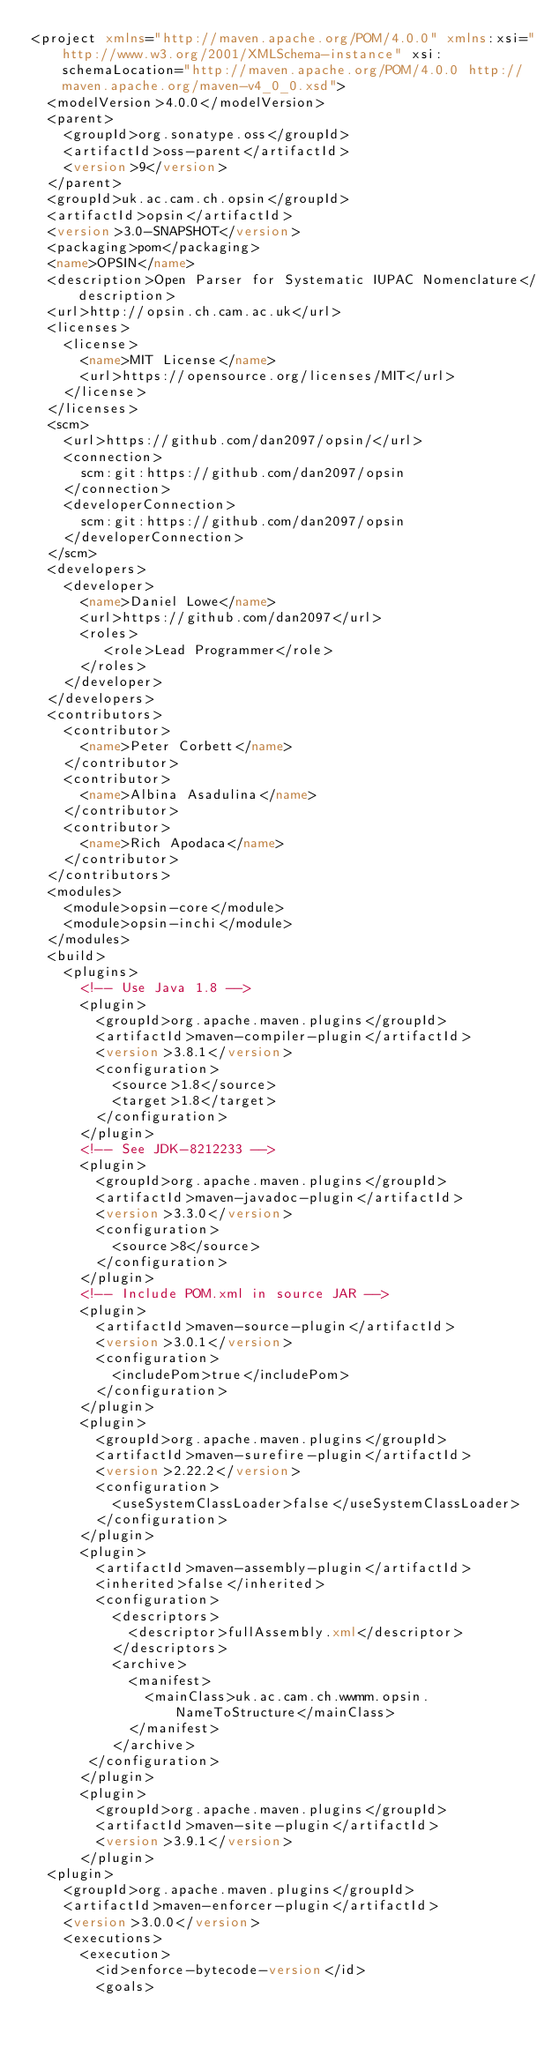Convert code to text. <code><loc_0><loc_0><loc_500><loc_500><_XML_><project xmlns="http://maven.apache.org/POM/4.0.0" xmlns:xsi="http://www.w3.org/2001/XMLSchema-instance" xsi:schemaLocation="http://maven.apache.org/POM/4.0.0 http://maven.apache.org/maven-v4_0_0.xsd">
  <modelVersion>4.0.0</modelVersion>
  <parent>
    <groupId>org.sonatype.oss</groupId>
    <artifactId>oss-parent</artifactId>
    <version>9</version>
  </parent>
  <groupId>uk.ac.cam.ch.opsin</groupId>
  <artifactId>opsin</artifactId>
  <version>3.0-SNAPSHOT</version>
  <packaging>pom</packaging>
  <name>OPSIN</name>
  <description>Open Parser for Systematic IUPAC Nomenclature</description>
  <url>http://opsin.ch.cam.ac.uk</url>
  <licenses>
    <license>
      <name>MIT License</name>
      <url>https://opensource.org/licenses/MIT</url>
    </license>
  </licenses>
  <scm>
    <url>https://github.com/dan2097/opsin/</url>
    <connection>
      scm:git:https://github.com/dan2097/opsin
    </connection>
    <developerConnection>
      scm:git:https://github.com/dan2097/opsin
    </developerConnection>
  </scm>
  <developers>
    <developer>
      <name>Daniel Lowe</name>
      <url>https://github.com/dan2097</url>
      <roles>
         <role>Lead Programmer</role>
      </roles>
    </developer>
  </developers>
  <contributors>
    <contributor>
      <name>Peter Corbett</name>
    </contributor>
    <contributor>
      <name>Albina Asadulina</name>
    </contributor>
    <contributor>
      <name>Rich Apodaca</name>
    </contributor>
  </contributors>
  <modules>
    <module>opsin-core</module>
    <module>opsin-inchi</module>
  </modules>
  <build>
    <plugins>
      <!-- Use Java 1.8 -->
      <plugin>
        <groupId>org.apache.maven.plugins</groupId>
        <artifactId>maven-compiler-plugin</artifactId>
        <version>3.8.1</version>
        <configuration>
          <source>1.8</source>
          <target>1.8</target>
        </configuration>
      </plugin>
      <!-- See JDK-8212233 -->
      <plugin>
        <groupId>org.apache.maven.plugins</groupId>
        <artifactId>maven-javadoc-plugin</artifactId>
        <version>3.3.0</version>
        <configuration>
          <source>8</source>
        </configuration>
      </plugin>
      <!-- Include POM.xml in source JAR -->
      <plugin>
        <artifactId>maven-source-plugin</artifactId>
        <version>3.0.1</version>
        <configuration>
          <includePom>true</includePom>
        </configuration>
      </plugin>
      <plugin>
        <groupId>org.apache.maven.plugins</groupId>
        <artifactId>maven-surefire-plugin</artifactId>
        <version>2.22.2</version>
        <configuration>
          <useSystemClassLoader>false</useSystemClassLoader>
        </configuration>
      </plugin>
      <plugin>
        <artifactId>maven-assembly-plugin</artifactId>
        <inherited>false</inherited>
        <configuration>
          <descriptors>
            <descriptor>fullAssembly.xml</descriptor>
          </descriptors>
          <archive>
            <manifest>
              <mainClass>uk.ac.cam.ch.wwmm.opsin.NameToStructure</mainClass>
            </manifest>
          </archive>
       </configuration>
      </plugin>
      <plugin>
        <groupId>org.apache.maven.plugins</groupId>
        <artifactId>maven-site-plugin</artifactId>
        <version>3.9.1</version>
      </plugin>
	<plugin>
		<groupId>org.apache.maven.plugins</groupId>
		<artifactId>maven-enforcer-plugin</artifactId>
		<version>3.0.0</version>
		<executions>
			<execution>
				<id>enforce-bytecode-version</id>
				<goals></code> 